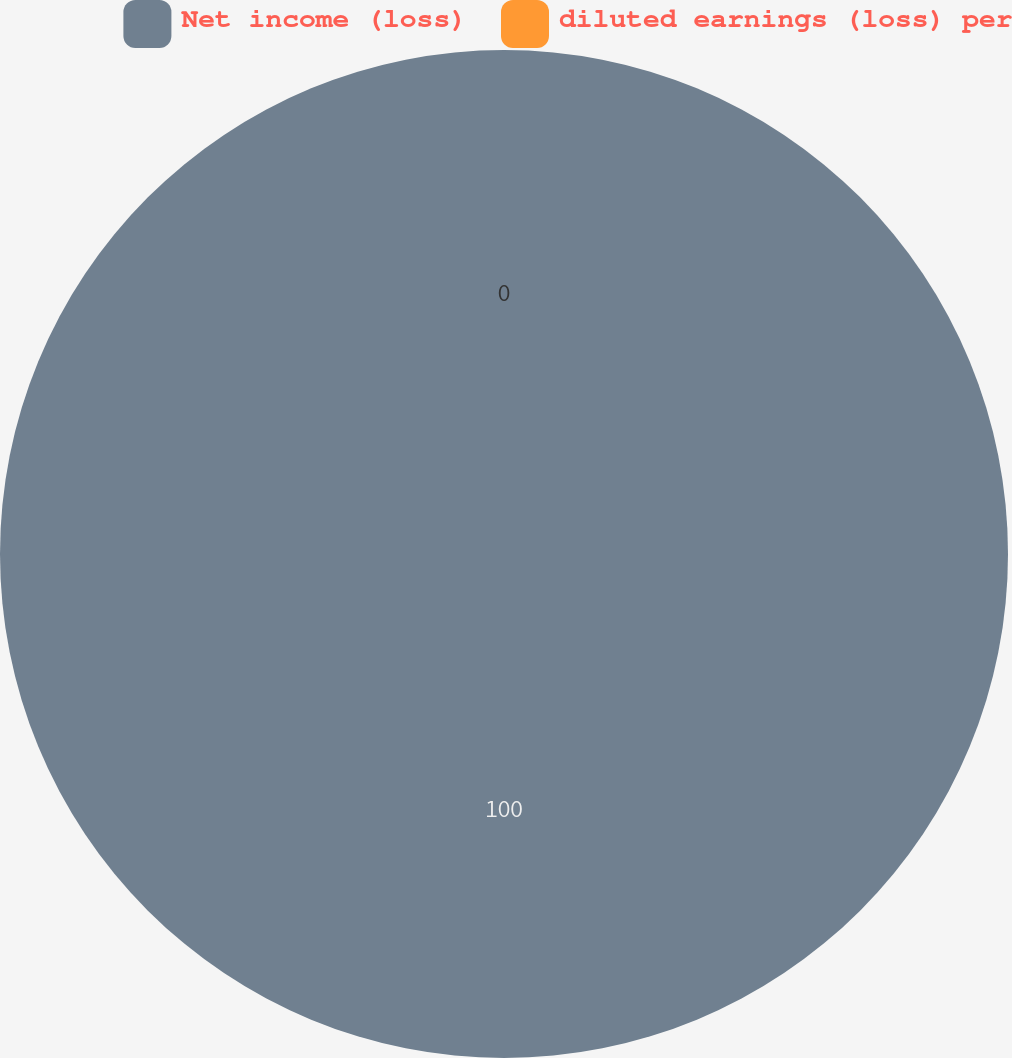Convert chart. <chart><loc_0><loc_0><loc_500><loc_500><pie_chart><fcel>Net income (loss)<fcel>diluted earnings (loss) per<nl><fcel>100.0%<fcel>0.0%<nl></chart> 